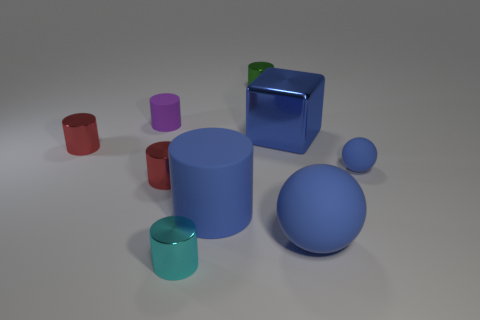Subtract all gray blocks. How many red cylinders are left? 2 Subtract all red cylinders. How many cylinders are left? 4 Subtract all blocks. How many objects are left? 8 Subtract all purple cylinders. How many cylinders are left? 5 Subtract 3 cylinders. How many cylinders are left? 3 Add 9 small cyan things. How many small cyan things exist? 10 Subtract 0 purple balls. How many objects are left? 9 Subtract all cyan balls. Subtract all green cylinders. How many balls are left? 2 Subtract all matte balls. Subtract all tiny purple things. How many objects are left? 6 Add 2 tiny purple objects. How many tiny purple objects are left? 3 